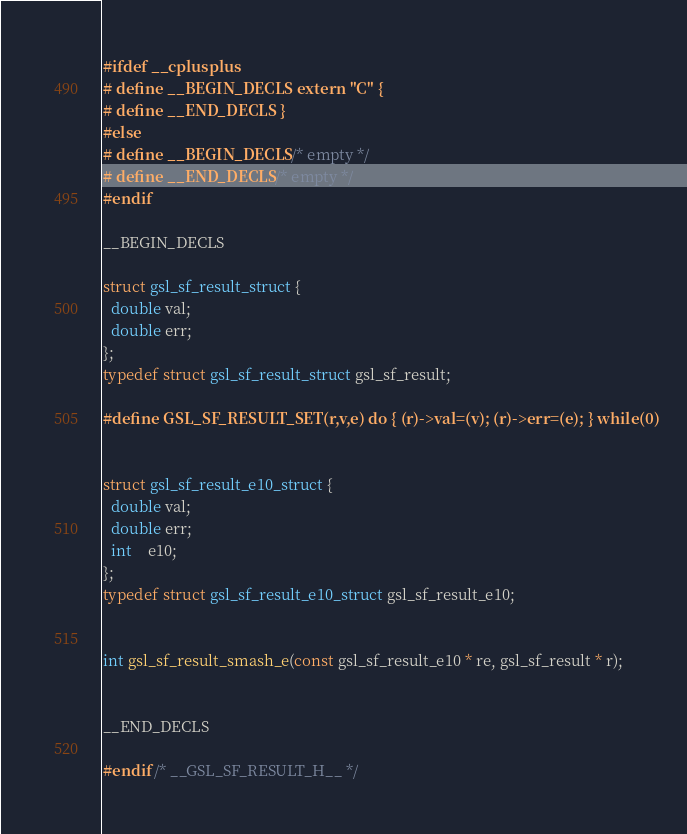Convert code to text. <code><loc_0><loc_0><loc_500><loc_500><_C_>#ifdef __cplusplus
# define __BEGIN_DECLS extern "C" {
# define __END_DECLS }
#else
# define __BEGIN_DECLS /* empty */
# define __END_DECLS /* empty */
#endif

__BEGIN_DECLS

struct gsl_sf_result_struct {
  double val;
  double err;
};
typedef struct gsl_sf_result_struct gsl_sf_result;

#define GSL_SF_RESULT_SET(r,v,e) do { (r)->val=(v); (r)->err=(e); } while(0)


struct gsl_sf_result_e10_struct {
  double val;
  double err;
  int    e10;
};
typedef struct gsl_sf_result_e10_struct gsl_sf_result_e10;


int gsl_sf_result_smash_e(const gsl_sf_result_e10 * re, gsl_sf_result * r);


__END_DECLS

#endif /* __GSL_SF_RESULT_H__ */
</code> 